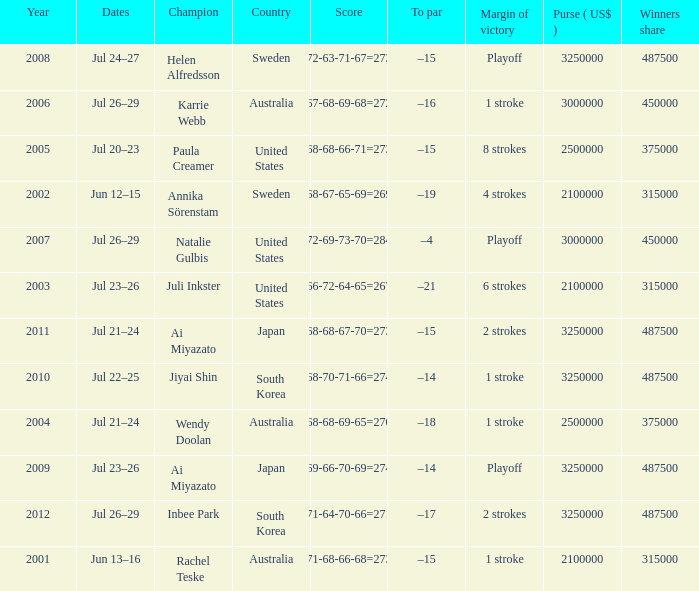I'm looking to parse the entire table for insights. Could you assist me with that? {'header': ['Year', 'Dates', 'Champion', 'Country', 'Score', 'To par', 'Margin of victory', 'Purse ( US$ )', 'Winners share'], 'rows': [['2008', 'Jul 24–27', 'Helen Alfredsson', 'Sweden', '72-63-71-67=273', '–15', 'Playoff', '3250000', '487500'], ['2006', 'Jul 26–29', 'Karrie Webb', 'Australia', '67-68-69-68=272', '–16', '1 stroke', '3000000', '450000'], ['2005', 'Jul 20–23', 'Paula Creamer', 'United States', '68-68-66-71=273', '–15', '8 strokes', '2500000', '375000'], ['2002', 'Jun 12–15', 'Annika Sörenstam', 'Sweden', '68-67-65-69=269', '–19', '4 strokes', '2100000', '315000'], ['2007', 'Jul 26–29', 'Natalie Gulbis', 'United States', '72-69-73-70=284', '–4', 'Playoff', '3000000', '450000'], ['2003', 'Jul 23–26', 'Juli Inkster', 'United States', '66-72-64-65=267', '–21', '6 strokes', '2100000', '315000'], ['2011', 'Jul 21–24', 'Ai Miyazato', 'Japan', '68-68-67-70=273', '–15', '2 strokes', '3250000', '487500'], ['2010', 'Jul 22–25', 'Jiyai Shin', 'South Korea', '68-70-71-66=274', '–14', '1 stroke', '3250000', '487500'], ['2004', 'Jul 21–24', 'Wendy Doolan', 'Australia', '68-68-69-65=270', '–18', '1 stroke', '2500000', '375000'], ['2009', 'Jul 23–26', 'Ai Miyazato', 'Japan', '69-66-70-69=274', '–14', 'Playoff', '3250000', '487500'], ['2012', 'Jul 26–29', 'Inbee Park', 'South Korea', '71-64-70-66=271', '–17', '2 strokes', '3250000', '487500'], ['2001', 'Jun 13–16', 'Rachel Teske', 'Australia', '71-68-66-68=273', '–15', '1 stroke', '2100000', '315000']]} What is the lowest year listed? 2001.0. 